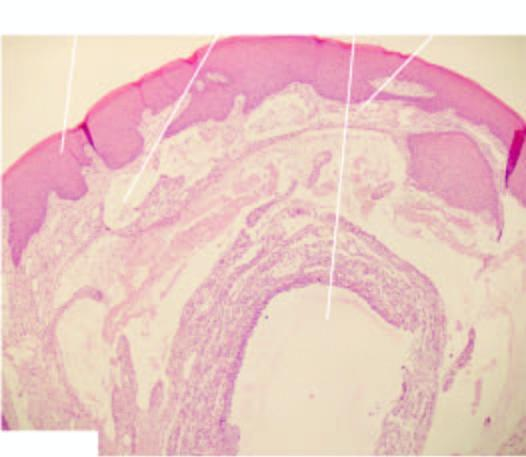what is there around extravasated mucus?
Answer the question using a single word or phrase. Inflammatory reaction 